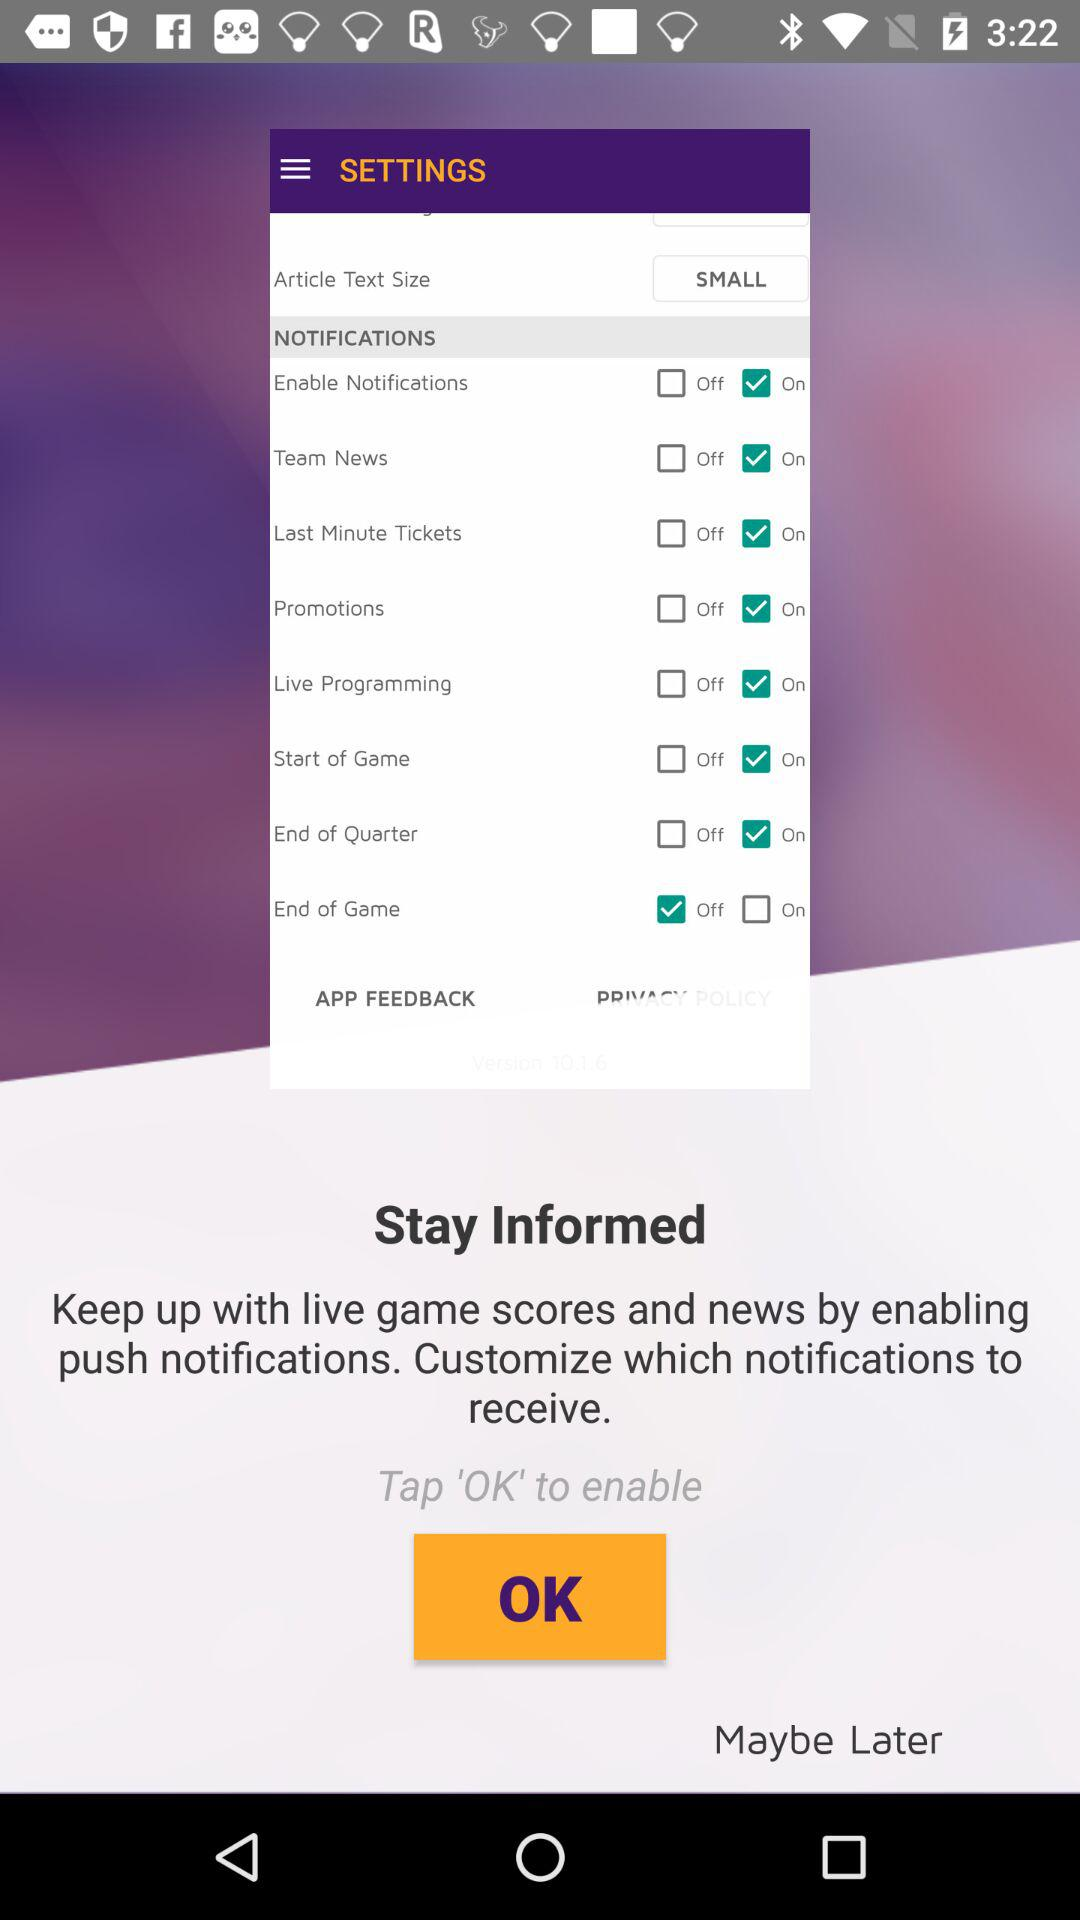What notification option is off? The option is "End of Game". 